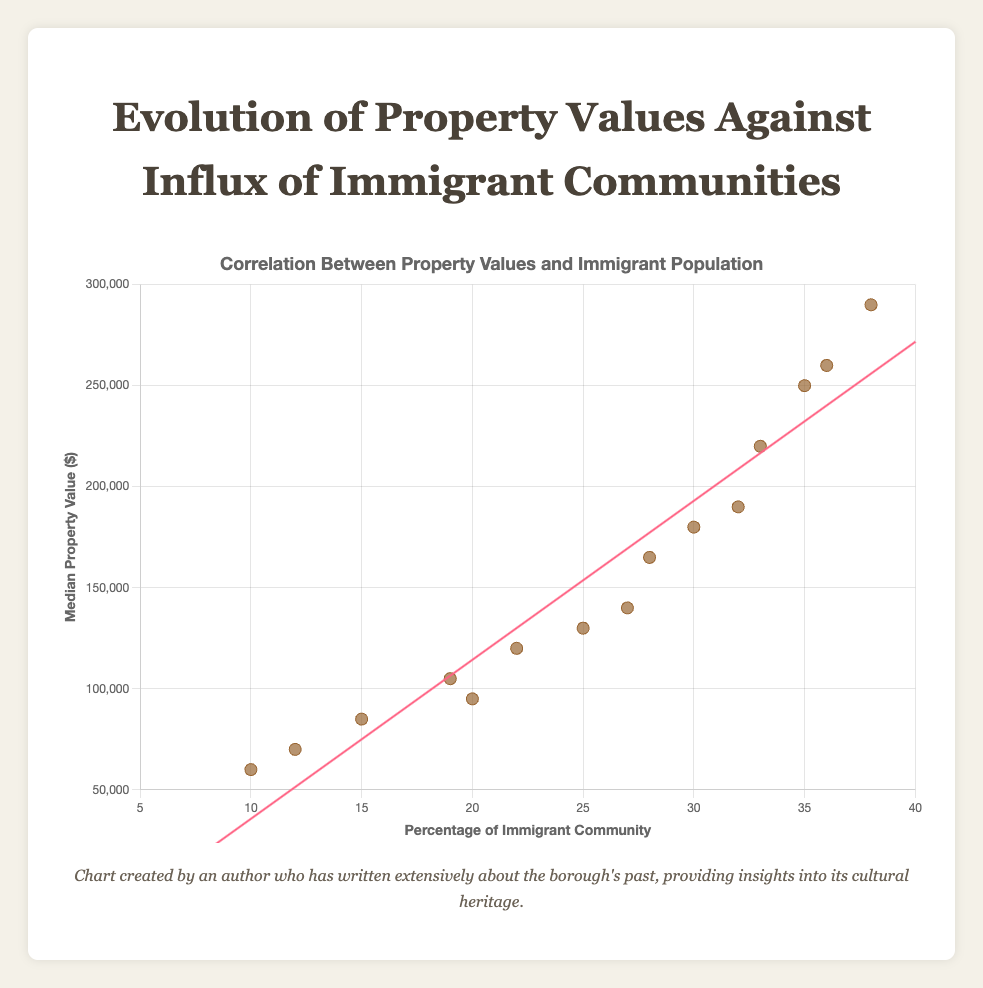What's the title of the chart? The title of the chart is usually found at the top. In this case, it is stated at the beginning of the document.
Answer: Evolution of Property Values Against Influx of Immigrant Communities What are the axes labels? The x-axis represents the "Percentage of Immigrant Community", and the y-axis represents the "Median Property Value ($)". These labels are visible next to the respective axes in the chart.
Answer: Percentage of Immigrant Community, Median Property Value ($) How many data points are shown in the chart? To count the number of data points, simply enumerate the (x, y) pairs provided in the dataset. Here, there are 15 such pairs.
Answer: 15 What's the general trend observed between immigrant percentage and property values? From the scatter plot with the trend line, we see a positive correlation indicating that as the percentage of the immigrant community increases, the median property value tends to increase as well. This can be observed from the upward slope of the trend line.
Answer: Positive correlation Which year has the lowest property value in the dataset? By comparing the property values across different years in the data table, we find that the year 1980 with the property value of 60000 has the lowest value.
Answer: 1980 What's the difference in median property value between the years 1980 and 2020 for the largest percentage of immigrant community? For 1980, the largest percentage of immigrant community is 15% with a property value of 85000, and for 2020, it's 38% with a property value of 290000. The difference is 290000 - 85000.
Answer: 205000 Which data point corresponds to the maximum percentage of the immigrant community, and what is its property value? By examining the data, the maximum percentage of the immigrant community is 38% in 2020, and the corresponding property value for this data point is 290000.
Answer: 38%, 290000 What is the range of percentages of the immigrant community shown in the chart? The range can be identified by subtracting the smallest percentage (10%) from the largest percentage (38%) in the dataset.
Answer: 28% What can be deduced about property values above $200,000 and the immigrant community percentage? Observing the chart, the data points with property values above $200,000 are associated with immigrant community percentages ranging from 30% to 38%.
Answer: 30% to 38% Comparing property values and immigrant percentages of two data points with the same year but different values, what trend can be observed? For instance, in the year 2020, two property values are $250,000 (35%) and $290,000 (38%). This comparison shows that within the same year, a higher immigrant community percentage correlates with higher property values.
Answer: Higher immigrant community percentage correlates with higher property values 